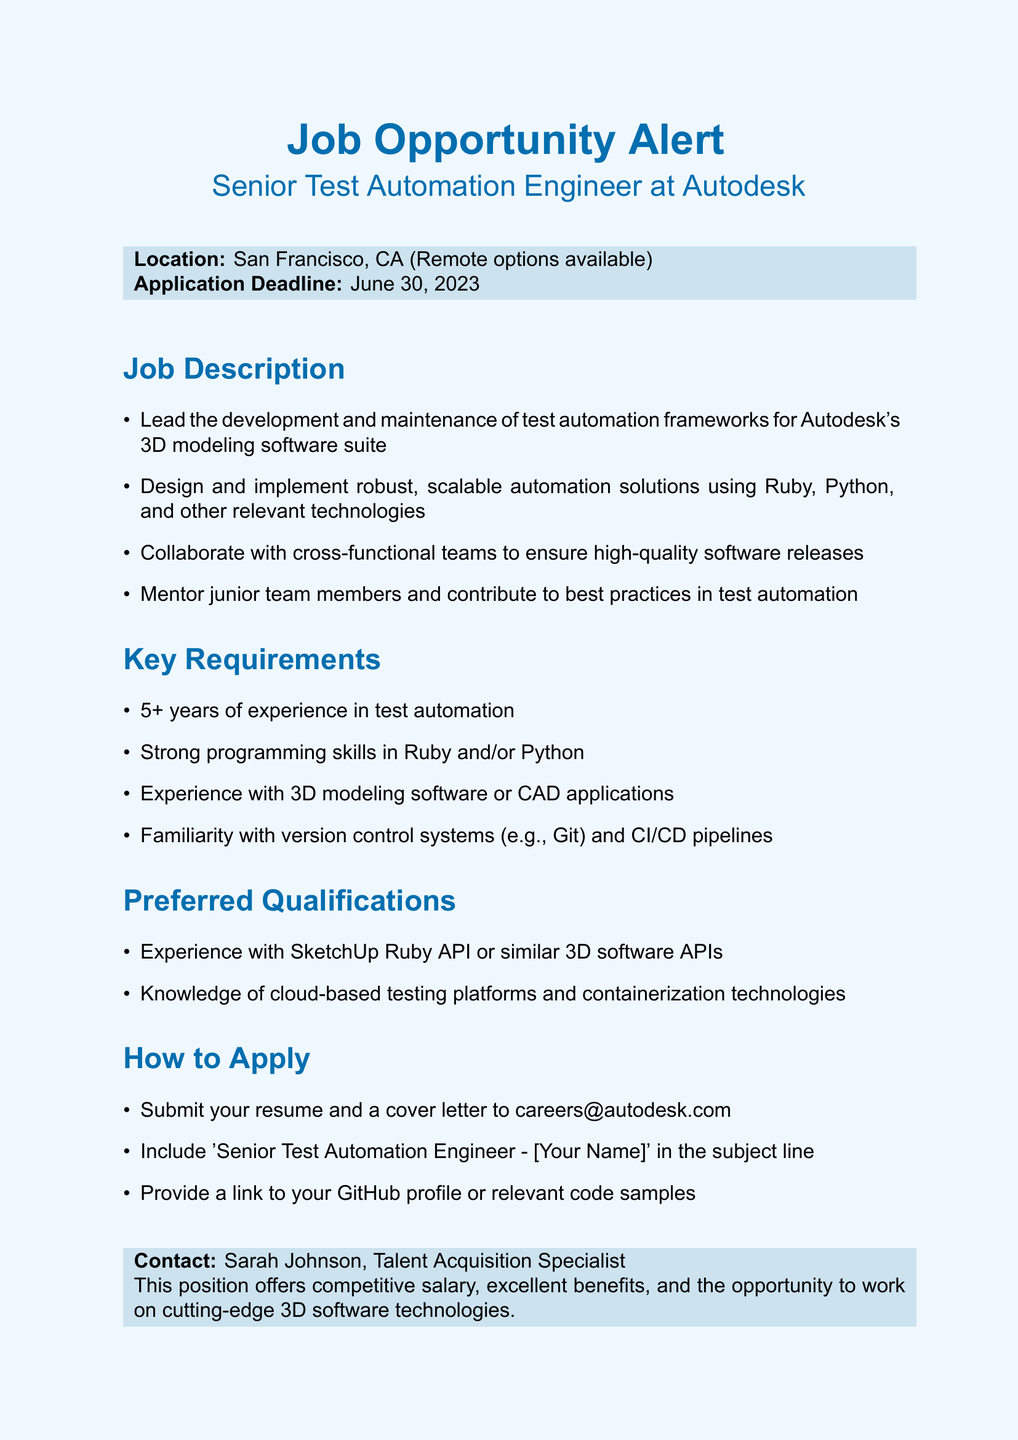What is the job title? The job title is explicitly mentioned in the document as "Senior Test Automation Engineer".
Answer: Senior Test Automation Engineer Where is the job located? The location is specified as "San Francisco, CA (Remote options available)".
Answer: San Francisco, CA (Remote options available) What is the application deadline? The document states the application deadline as "June 30, 2023".
Answer: June 30, 2023 How many years of experience are required? The job requires "5+ years of experience in test automation".
Answer: 5+ years Who is the contact person for the job? The document provides the contact person’s name as "Sarah Johnson, Talent Acquisition Specialist".
Answer: Sarah Johnson What programming languages are needed for the job? The document lists "Ruby and/or Python" as the required programming skills.
Answer: Ruby and/or Python What is one preferred qualification? The document mentions "Experience with SketchUp Ruby API or similar 3D software APIs" as a preferred qualification.
Answer: Experience with SketchUp Ruby API What should be included in the application email subject line? The document instructs to include "Senior Test Automation Engineer - [Your Name]" in the subject line.
Answer: Senior Test Automation Engineer - [Your Name] What type of position is this? The position is characterized as a "senior" role in test automation.
Answer: senior 